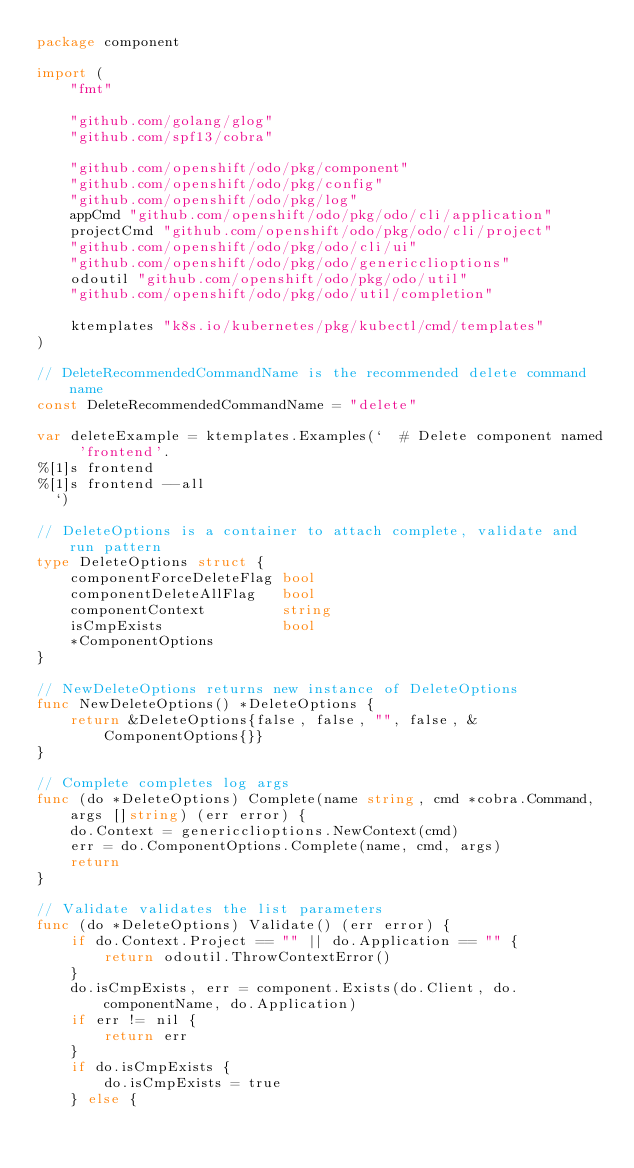<code> <loc_0><loc_0><loc_500><loc_500><_Go_>package component

import (
	"fmt"

	"github.com/golang/glog"
	"github.com/spf13/cobra"

	"github.com/openshift/odo/pkg/component"
	"github.com/openshift/odo/pkg/config"
	"github.com/openshift/odo/pkg/log"
	appCmd "github.com/openshift/odo/pkg/odo/cli/application"
	projectCmd "github.com/openshift/odo/pkg/odo/cli/project"
	"github.com/openshift/odo/pkg/odo/cli/ui"
	"github.com/openshift/odo/pkg/odo/genericclioptions"
	odoutil "github.com/openshift/odo/pkg/odo/util"
	"github.com/openshift/odo/pkg/odo/util/completion"

	ktemplates "k8s.io/kubernetes/pkg/kubectl/cmd/templates"
)

// DeleteRecommendedCommandName is the recommended delete command name
const DeleteRecommendedCommandName = "delete"

var deleteExample = ktemplates.Examples(`  # Delete component named 'frontend'. 
%[1]s frontend
%[1]s frontend --all
  `)

// DeleteOptions is a container to attach complete, validate and run pattern
type DeleteOptions struct {
	componentForceDeleteFlag bool
	componentDeleteAllFlag   bool
	componentContext         string
	isCmpExists              bool
	*ComponentOptions
}

// NewDeleteOptions returns new instance of DeleteOptions
func NewDeleteOptions() *DeleteOptions {
	return &DeleteOptions{false, false, "", false, &ComponentOptions{}}
}

// Complete completes log args
func (do *DeleteOptions) Complete(name string, cmd *cobra.Command, args []string) (err error) {
	do.Context = genericclioptions.NewContext(cmd)
	err = do.ComponentOptions.Complete(name, cmd, args)
	return
}

// Validate validates the list parameters
func (do *DeleteOptions) Validate() (err error) {
	if do.Context.Project == "" || do.Application == "" {
		return odoutil.ThrowContextError()
	}
	do.isCmpExists, err = component.Exists(do.Client, do.componentName, do.Application)
	if err != nil {
		return err
	}
	if do.isCmpExists {
		do.isCmpExists = true
	} else {</code> 